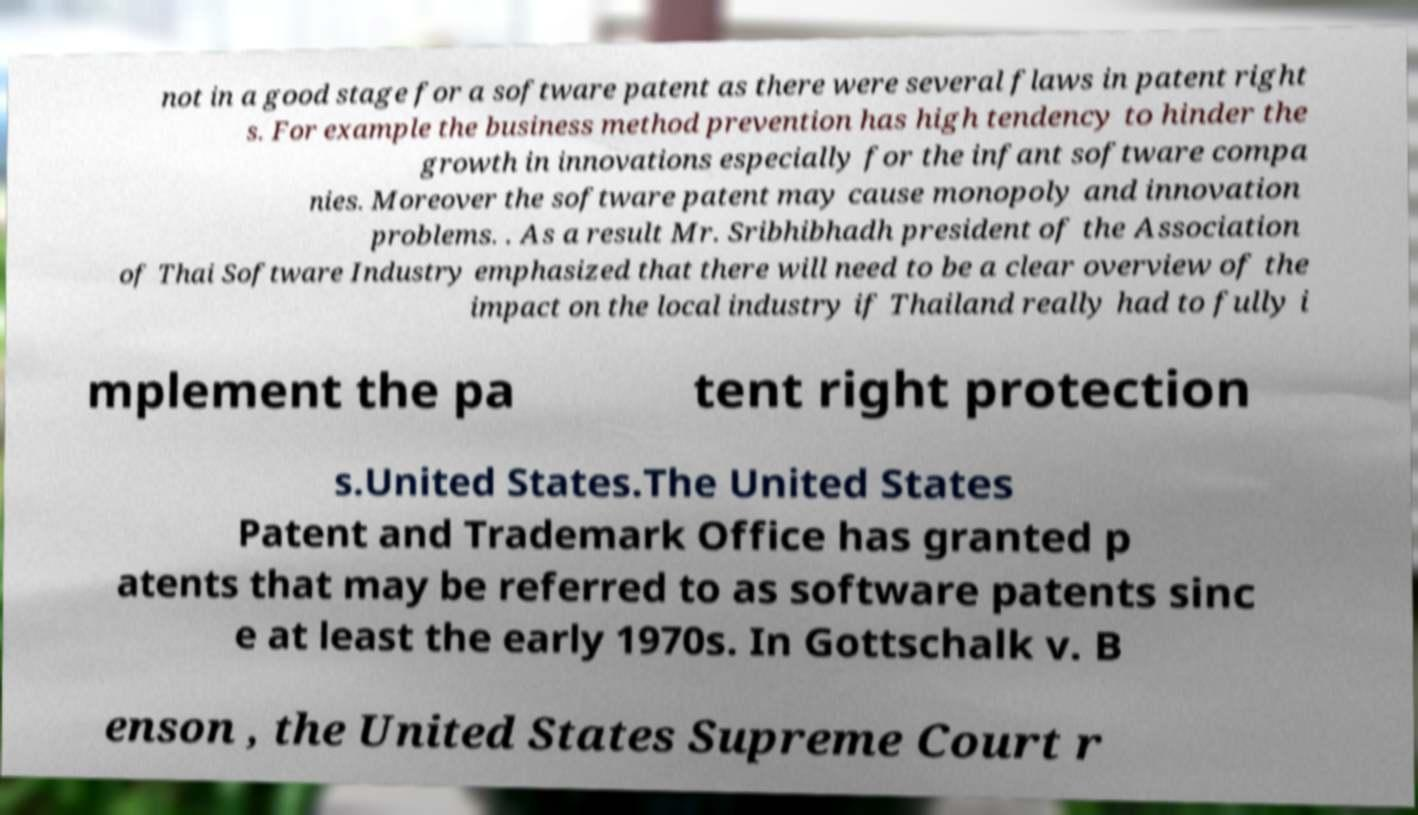Could you extract and type out the text from this image? not in a good stage for a software patent as there were several flaws in patent right s. For example the business method prevention has high tendency to hinder the growth in innovations especially for the infant software compa nies. Moreover the software patent may cause monopoly and innovation problems. . As a result Mr. Sribhibhadh president of the Association of Thai Software Industry emphasized that there will need to be a clear overview of the impact on the local industry if Thailand really had to fully i mplement the pa tent right protection s.United States.The United States Patent and Trademark Office has granted p atents that may be referred to as software patents sinc e at least the early 1970s. In Gottschalk v. B enson , the United States Supreme Court r 